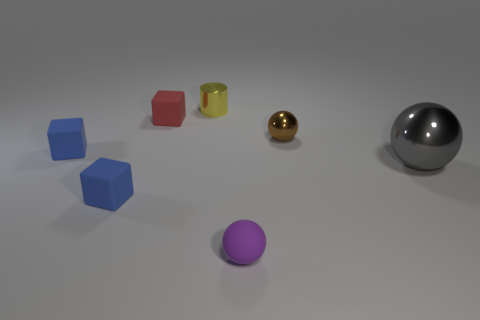Add 1 big brown metal objects. How many objects exist? 8 Subtract all balls. How many objects are left? 4 Subtract all matte objects. Subtract all red rubber objects. How many objects are left? 2 Add 7 large metallic balls. How many large metallic balls are left? 8 Add 5 gray shiny spheres. How many gray shiny spheres exist? 6 Subtract 0 cyan cylinders. How many objects are left? 7 